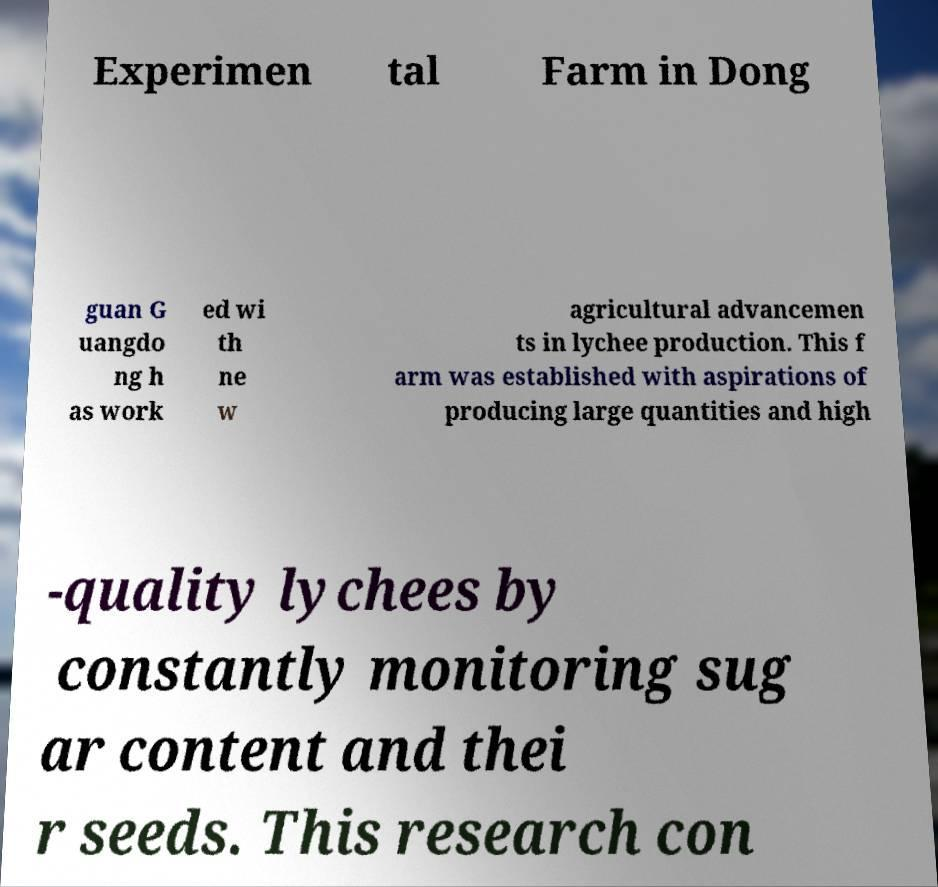Please identify and transcribe the text found in this image. Experimen tal Farm in Dong guan G uangdo ng h as work ed wi th ne w agricultural advancemen ts in lychee production. This f arm was established with aspirations of producing large quantities and high -quality lychees by constantly monitoring sug ar content and thei r seeds. This research con 